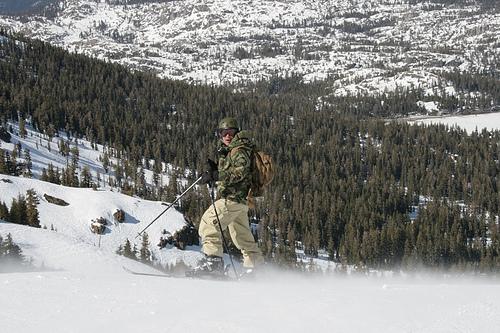What color is the man's jacket?
Keep it brief. Camouflage. Is it a warm day?
Quick response, please. No. What is the location where the man is skiing?
Be succinct. Mountain. Is this person male or female?
Short answer required. Male. 